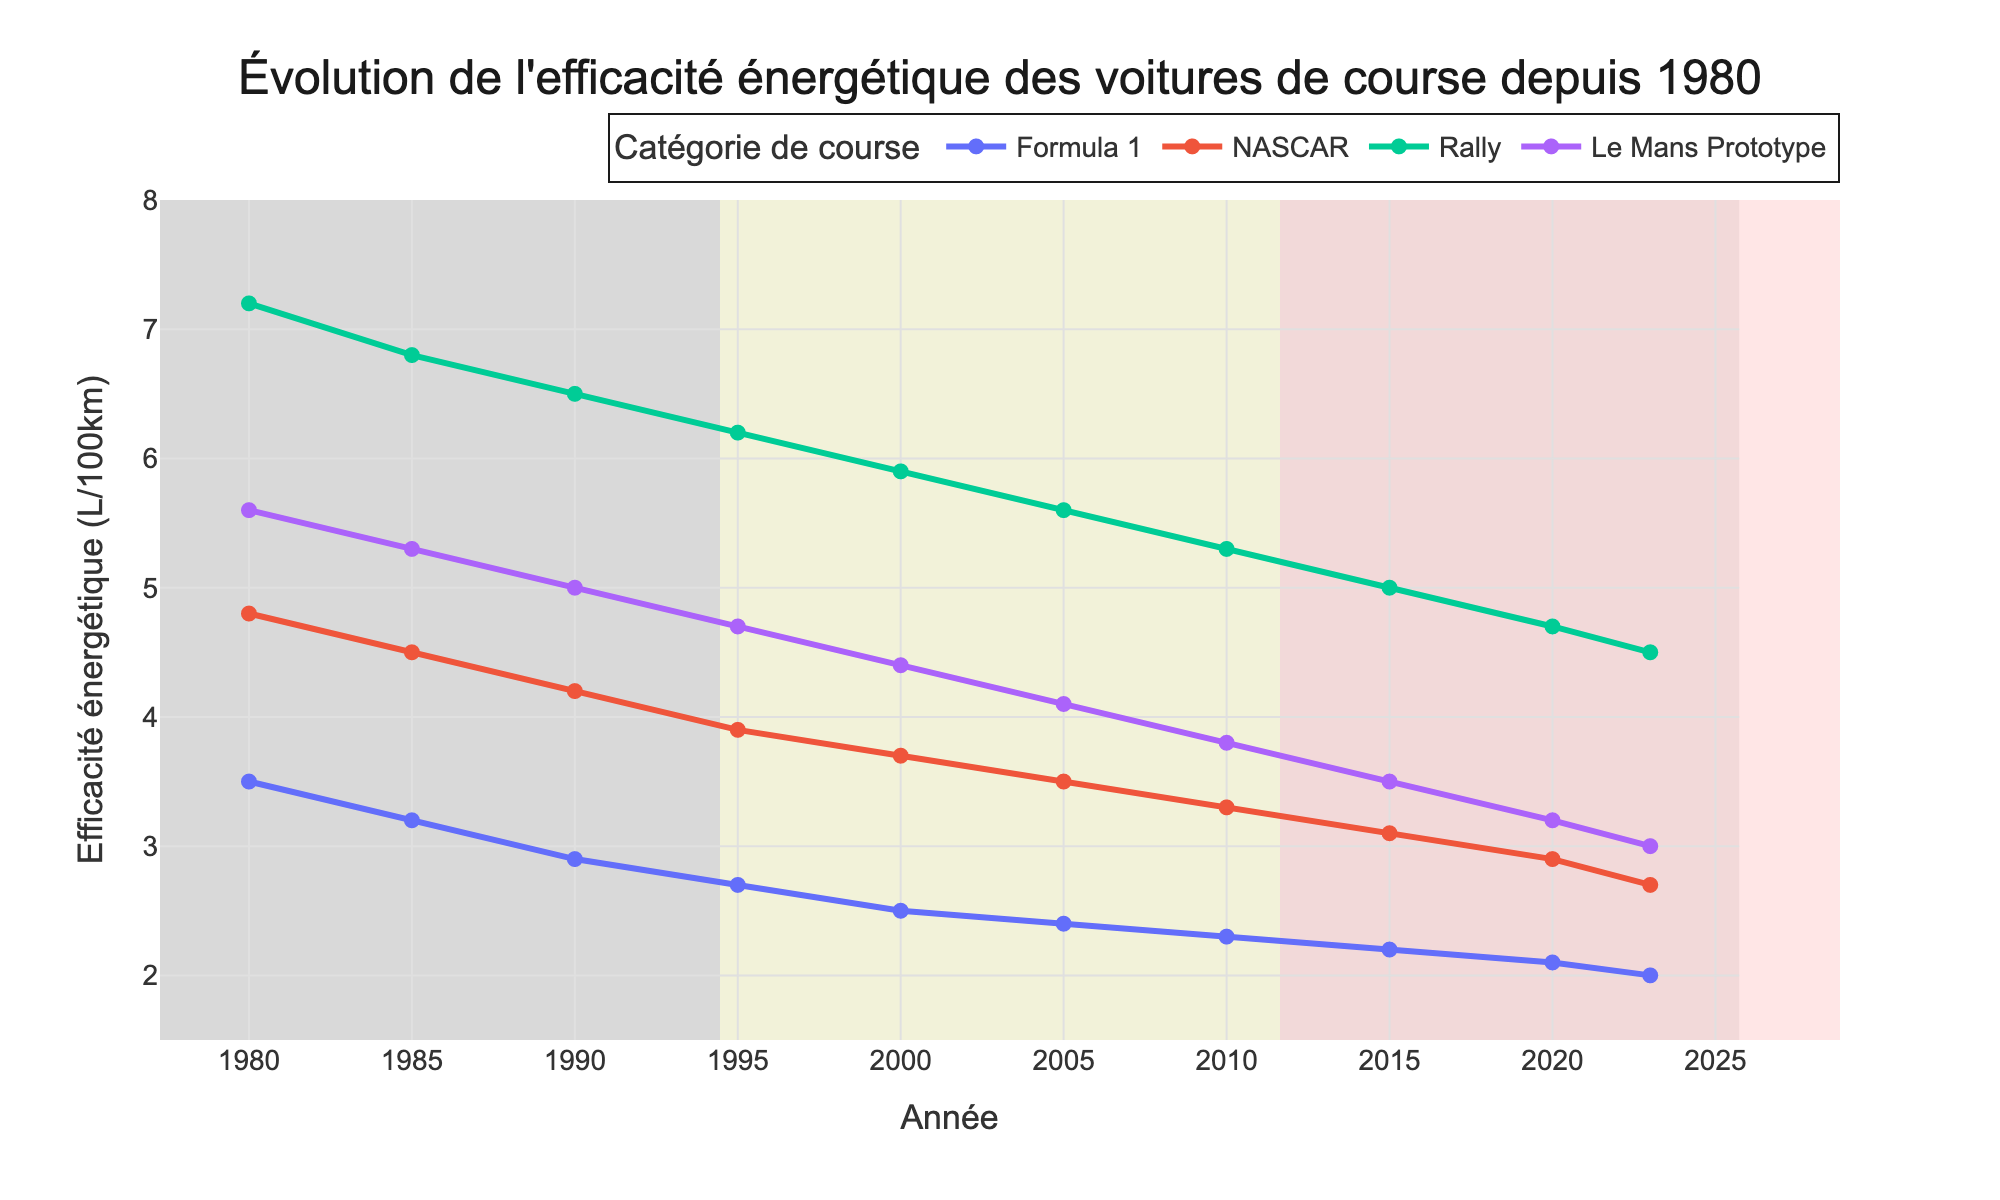what is the overall trend in fuel efficiency for Formula 1 from 1980 to 2023? The Formula 1 series shows a decreasing trend in fuel consumption, starting from 3.5 L/100km in 1980 and reducing to 2.0 L/100km in 2023. This indicates improvements in fuel efficiency over the years.
Answer: decreasing trend which racing category had the highest fuel efficiency improvement between 1980 and 2023? To determine this, we need to look at the reduction in L/100km for each category. Formula 1 improved from 3.5 to 2.0 (1.5), NASCAR from 4.8 to 2.7 (2.1), Rally from 7.2 to 4.5 (2.7), and Le Mans Prototype from 5.6 to 3.0 (2.6). Rally had the highest improvement with a 2.7 L/100km reduction.
Answer: Rally by how much did fuel efficiency for NASCAR cars improve from 1995 to 2023? In 1995, NASCAR's fuel efficiency was 3.9 L/100km, and it improved to 2.7 L/100km in 2023. The improvement is 3.9 - 2.7 = 1.2 L/100km.
Answer: 1.2 L/100km which category had the least improvement in fuel efficiency from 1980 to 2023? To determine this, we compare the reductions: Formula 1 improved by 1.5, NASCAR by 2.1, Rally by 2.7, and Le Mans Prototype by 2.6. Formula 1 had the least improvement with a reduction of 1.5 L/100km.
Answer: Formula 1 what is the average fuel efficiency for Rally cars over the entire period shown in the figure? The values for Rally from 1980 to 2023 are: 7.2, 6.8, 6.5, 6.2, 5.9, 5.6, 5.3, 5.0, 4.7, 4.5. Summing these values gives 57.7. Dividing by the number of data points (10), the average is 57.7 / 10 = 5.77 L/100km.
Answer: 5.77 L/100km which year showed the biggest drop in fuel efficiency for Le Mans Prototype cars? By examining the year-to-year changes, the largest drop occurred between 2010 (3.8 L/100km) and 2015 (3.5 L/100km). The change is 0.3 L/100km.
Answer: 2010 to 2015 in 2020, how much more fuel-efficient were Rally cars compared to Formula 1 cars? In 2020, Rally cars had a fuel efficiency of 4.7 L/100km and Formula 1 had 2.1 L/100km. The difference is 4.7 - 2.1 = 2.6 L/100km.
Answer: 2.6 L/100km what common trend can you observe for all car categories from 1980 to 2023? All car categories (Formula 1, NASCAR, Rally, and Le Mans Prototype) show a decreasing trend in their fuel consumption over the period, indicating improvements in fuel efficiency.
Answer: decreasing trend 